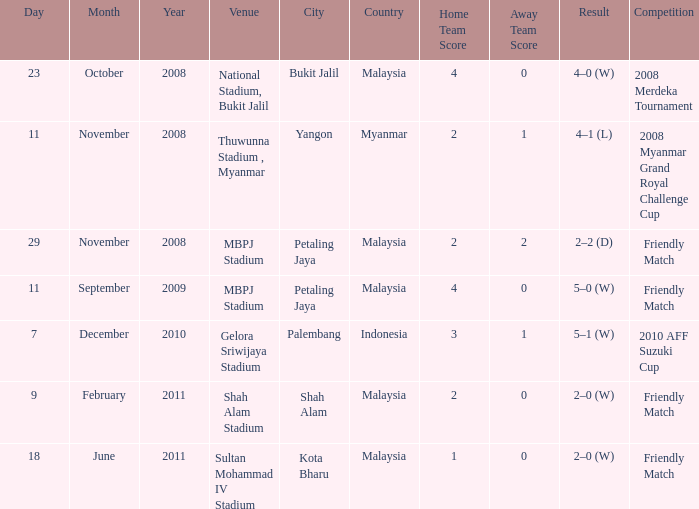What Competition had a Score of 2–0? Friendly Match. 